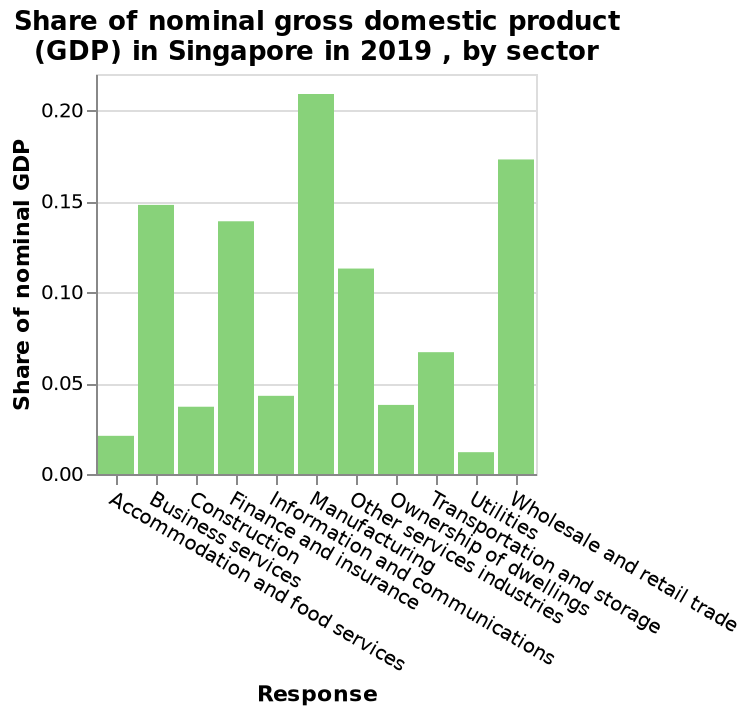<image>
What does the x-axis represent in the bar chart? The x-axis represents different sectors, starting from "Accommodation and food services" and ending at "Wholesale and retail trade." please summary the statistics and relations of the chart Manufacturing  had the largest share of nominal GDP in Singapore  in 2019. The manufacturing share was over 0.20 GDP. Utilities had the smallest shre of nominal GDP in Singapore in 2019. please enumerates aspects of the construction of the chart Here a is a bar chart titled Share of nominal gross domestic product (GDP) in Singapore in 2019 , by sector. On the x-axis, Response is shown with a categorical scale starting at Accommodation and food services and ending at Wholesale and retail trade. Along the y-axis, Share of nominal GDP is plotted. Which sector had a GDP of 0.21? Manufacturing had a GDP of 0.21. 